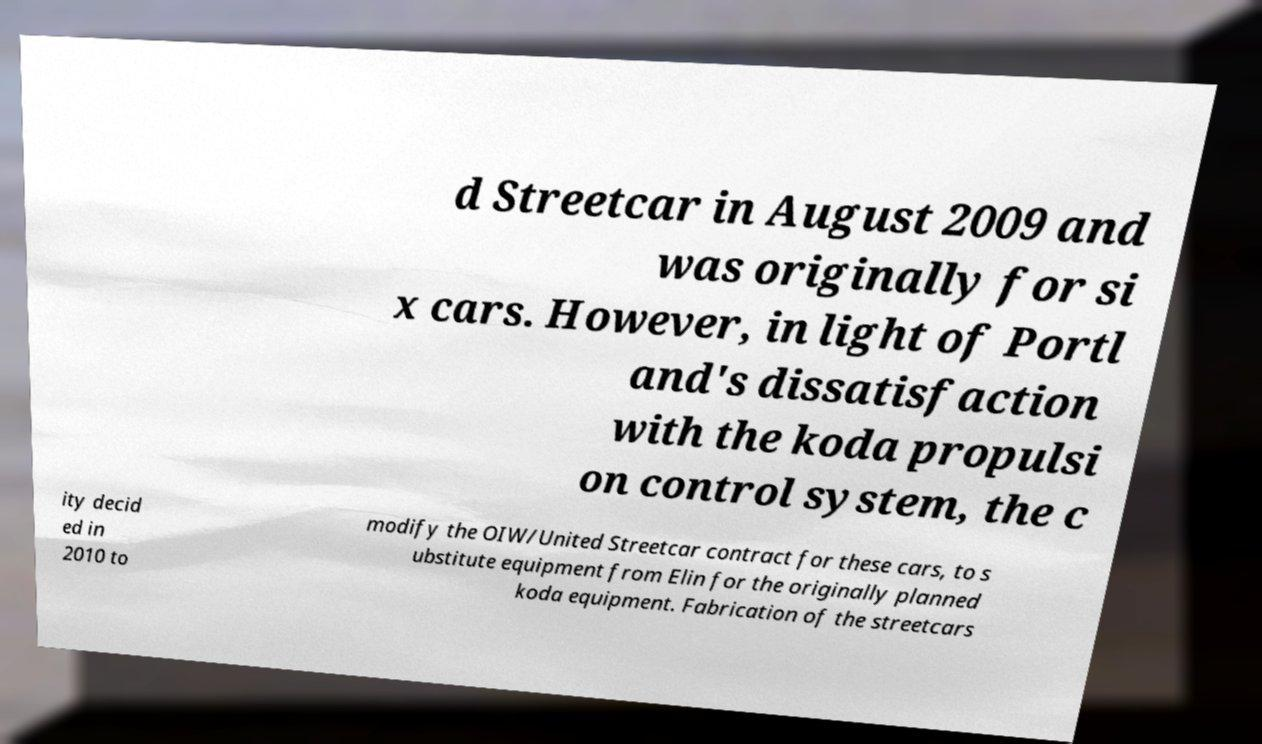Can you accurately transcribe the text from the provided image for me? d Streetcar in August 2009 and was originally for si x cars. However, in light of Portl and's dissatisfaction with the koda propulsi on control system, the c ity decid ed in 2010 to modify the OIW/United Streetcar contract for these cars, to s ubstitute equipment from Elin for the originally planned koda equipment. Fabrication of the streetcars 